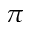<formula> <loc_0><loc_0><loc_500><loc_500>\pi</formula> 